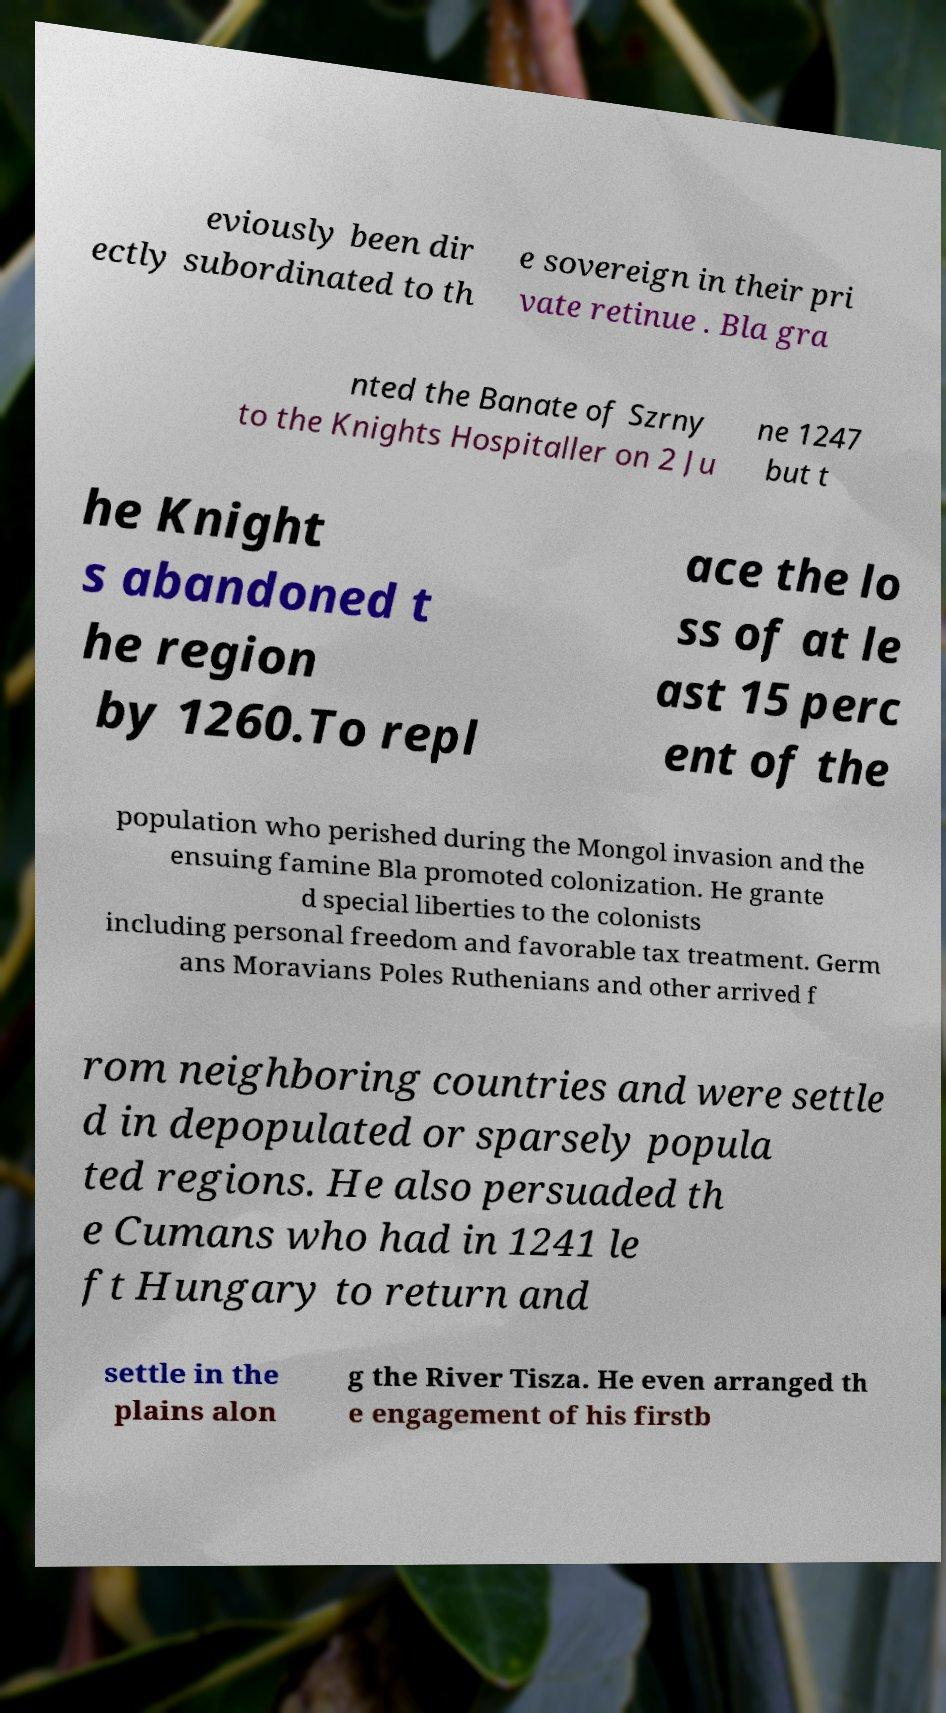There's text embedded in this image that I need extracted. Can you transcribe it verbatim? eviously been dir ectly subordinated to th e sovereign in their pri vate retinue . Bla gra nted the Banate of Szrny to the Knights Hospitaller on 2 Ju ne 1247 but t he Knight s abandoned t he region by 1260.To repl ace the lo ss of at le ast 15 perc ent of the population who perished during the Mongol invasion and the ensuing famine Bla promoted colonization. He grante d special liberties to the colonists including personal freedom and favorable tax treatment. Germ ans Moravians Poles Ruthenians and other arrived f rom neighboring countries and were settle d in depopulated or sparsely popula ted regions. He also persuaded th e Cumans who had in 1241 le ft Hungary to return and settle in the plains alon g the River Tisza. He even arranged th e engagement of his firstb 